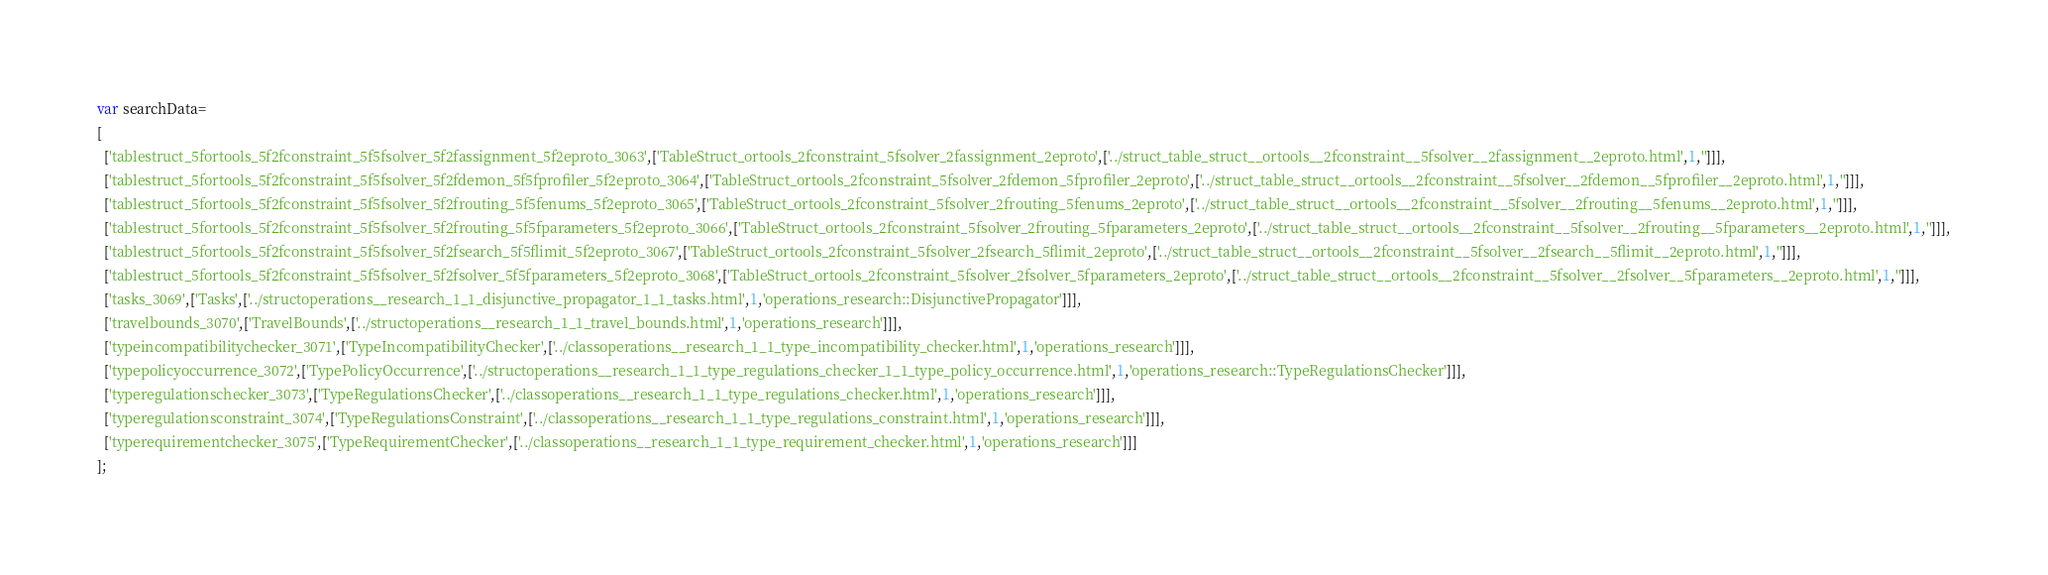<code> <loc_0><loc_0><loc_500><loc_500><_JavaScript_>var searchData=
[
  ['tablestruct_5fortools_5f2fconstraint_5f5fsolver_5f2fassignment_5f2eproto_3063',['TableStruct_ortools_2fconstraint_5fsolver_2fassignment_2eproto',['../struct_table_struct__ortools__2fconstraint__5fsolver__2fassignment__2eproto.html',1,'']]],
  ['tablestruct_5fortools_5f2fconstraint_5f5fsolver_5f2fdemon_5f5fprofiler_5f2eproto_3064',['TableStruct_ortools_2fconstraint_5fsolver_2fdemon_5fprofiler_2eproto',['../struct_table_struct__ortools__2fconstraint__5fsolver__2fdemon__5fprofiler__2eproto.html',1,'']]],
  ['tablestruct_5fortools_5f2fconstraint_5f5fsolver_5f2frouting_5f5fenums_5f2eproto_3065',['TableStruct_ortools_2fconstraint_5fsolver_2frouting_5fenums_2eproto',['../struct_table_struct__ortools__2fconstraint__5fsolver__2frouting__5fenums__2eproto.html',1,'']]],
  ['tablestruct_5fortools_5f2fconstraint_5f5fsolver_5f2frouting_5f5fparameters_5f2eproto_3066',['TableStruct_ortools_2fconstraint_5fsolver_2frouting_5fparameters_2eproto',['../struct_table_struct__ortools__2fconstraint__5fsolver__2frouting__5fparameters__2eproto.html',1,'']]],
  ['tablestruct_5fortools_5f2fconstraint_5f5fsolver_5f2fsearch_5f5flimit_5f2eproto_3067',['TableStruct_ortools_2fconstraint_5fsolver_2fsearch_5flimit_2eproto',['../struct_table_struct__ortools__2fconstraint__5fsolver__2fsearch__5flimit__2eproto.html',1,'']]],
  ['tablestruct_5fortools_5f2fconstraint_5f5fsolver_5f2fsolver_5f5fparameters_5f2eproto_3068',['TableStruct_ortools_2fconstraint_5fsolver_2fsolver_5fparameters_2eproto',['../struct_table_struct__ortools__2fconstraint__5fsolver__2fsolver__5fparameters__2eproto.html',1,'']]],
  ['tasks_3069',['Tasks',['../structoperations__research_1_1_disjunctive_propagator_1_1_tasks.html',1,'operations_research::DisjunctivePropagator']]],
  ['travelbounds_3070',['TravelBounds',['../structoperations__research_1_1_travel_bounds.html',1,'operations_research']]],
  ['typeincompatibilitychecker_3071',['TypeIncompatibilityChecker',['../classoperations__research_1_1_type_incompatibility_checker.html',1,'operations_research']]],
  ['typepolicyoccurrence_3072',['TypePolicyOccurrence',['../structoperations__research_1_1_type_regulations_checker_1_1_type_policy_occurrence.html',1,'operations_research::TypeRegulationsChecker']]],
  ['typeregulationschecker_3073',['TypeRegulationsChecker',['../classoperations__research_1_1_type_regulations_checker.html',1,'operations_research']]],
  ['typeregulationsconstraint_3074',['TypeRegulationsConstraint',['../classoperations__research_1_1_type_regulations_constraint.html',1,'operations_research']]],
  ['typerequirementchecker_3075',['TypeRequirementChecker',['../classoperations__research_1_1_type_requirement_checker.html',1,'operations_research']]]
];
</code> 